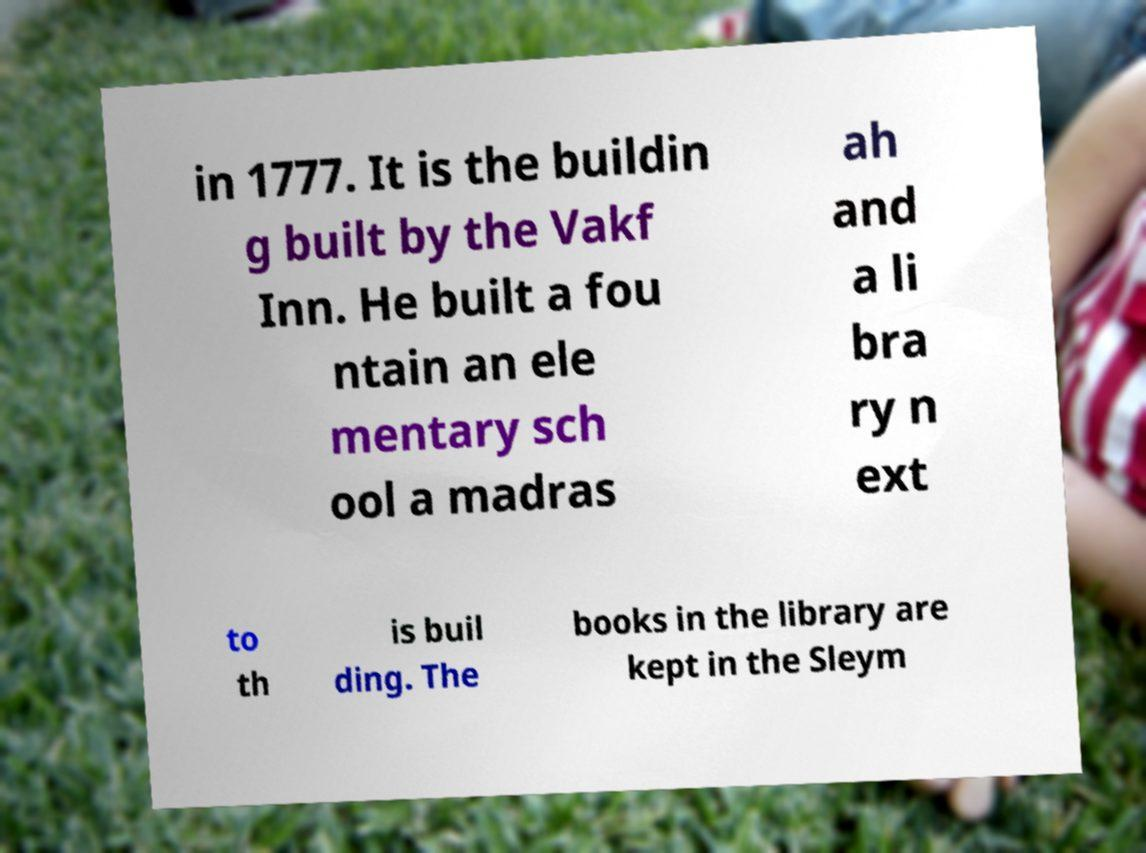I need the written content from this picture converted into text. Can you do that? in 1777. It is the buildin g built by the Vakf Inn. He built a fou ntain an ele mentary sch ool a madras ah and a li bra ry n ext to th is buil ding. The books in the library are kept in the Sleym 